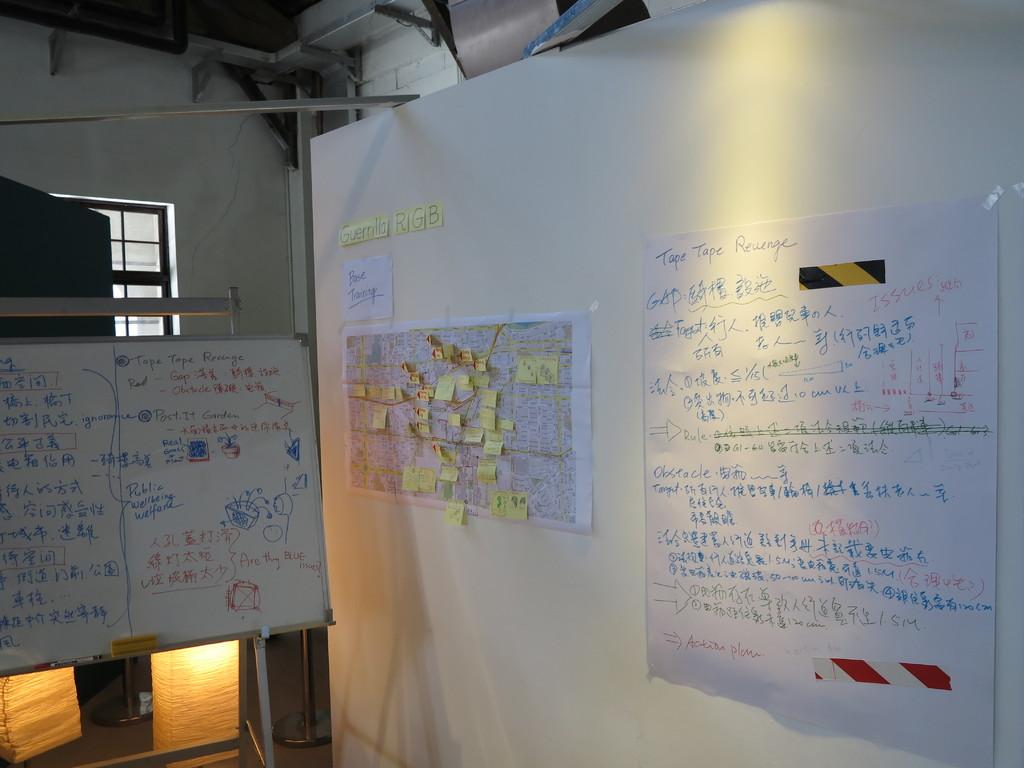What is the project on the white board?
Offer a terse response. Unanswerable. What three letters are on the yellow post it notes?
Offer a terse response. Rgb. 